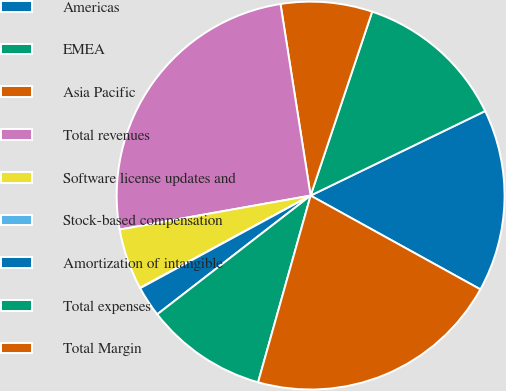Convert chart. <chart><loc_0><loc_0><loc_500><loc_500><pie_chart><fcel>Americas<fcel>EMEA<fcel>Asia Pacific<fcel>Total revenues<fcel>Software license updates and<fcel>Stock-based compensation<fcel>Amortization of intangible<fcel>Total expenses<fcel>Total Margin<nl><fcel>15.21%<fcel>12.68%<fcel>7.62%<fcel>25.32%<fcel>5.09%<fcel>0.03%<fcel>2.56%<fcel>10.15%<fcel>21.33%<nl></chart> 